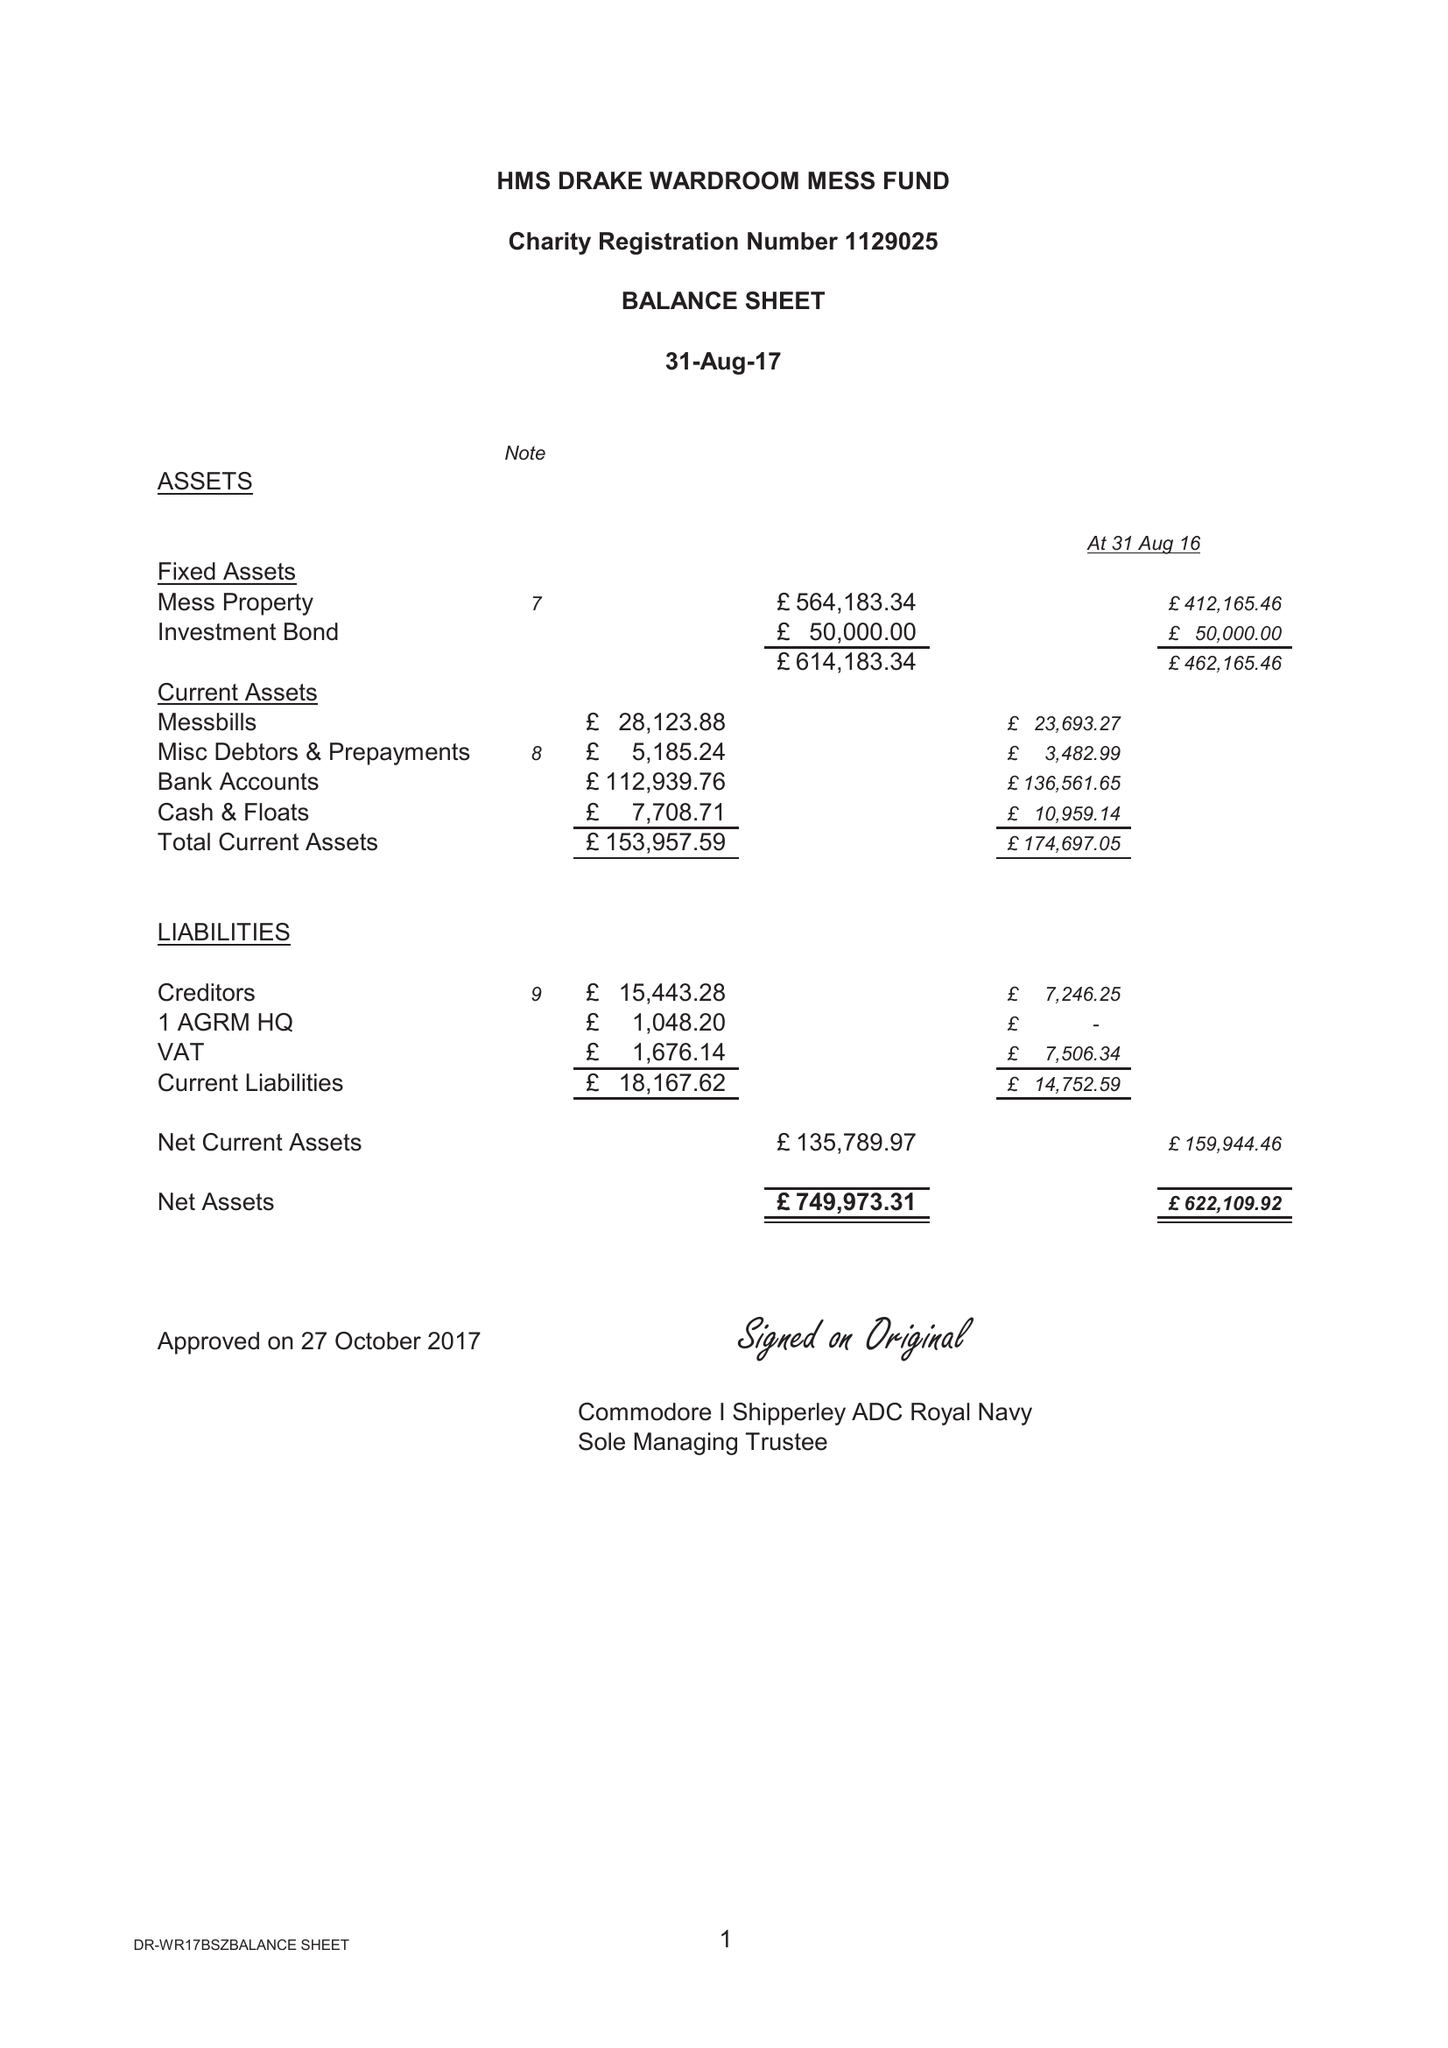What is the value for the report_date?
Answer the question using a single word or phrase. 2017-08-31 